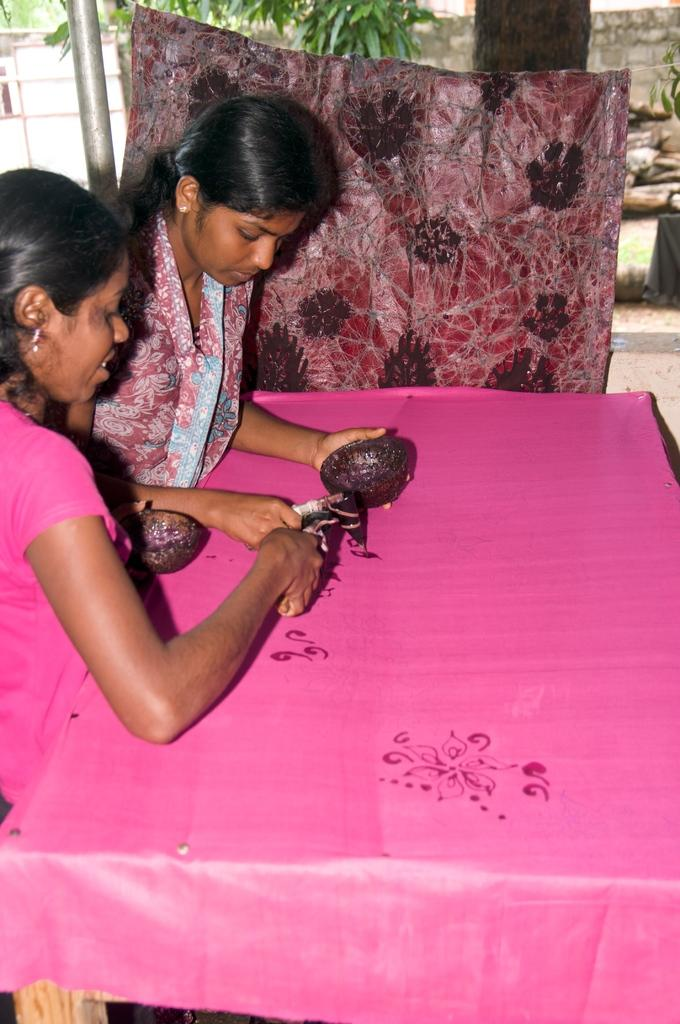How many people are present in the image? There are two women in the image. What are the women doing in the image? The women are painting a cloth in the image. Where is the cloth located? The cloth is on a table in the image. What can be seen in the background of the image? There is a tree and a house visible in the image. What type of nerve can be seen in the image? There is no nerve present in the image. Is there a bed visible in the image? No, there is no bed visible in the image. 